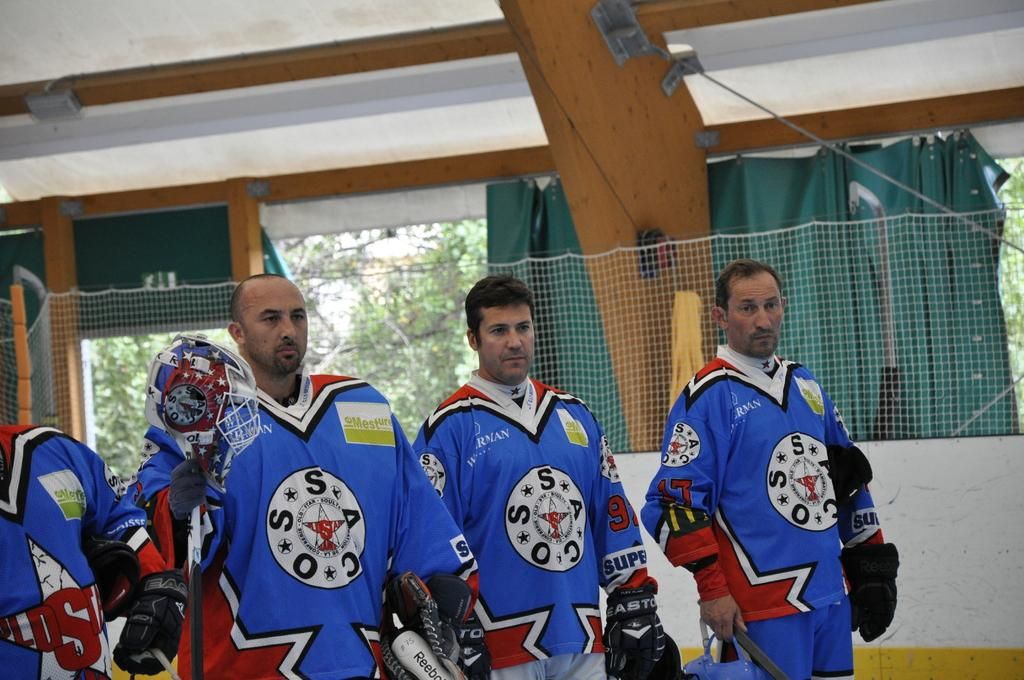<image>
Write a terse but informative summary of the picture. Four members of the OSSC hockey team in blue. 